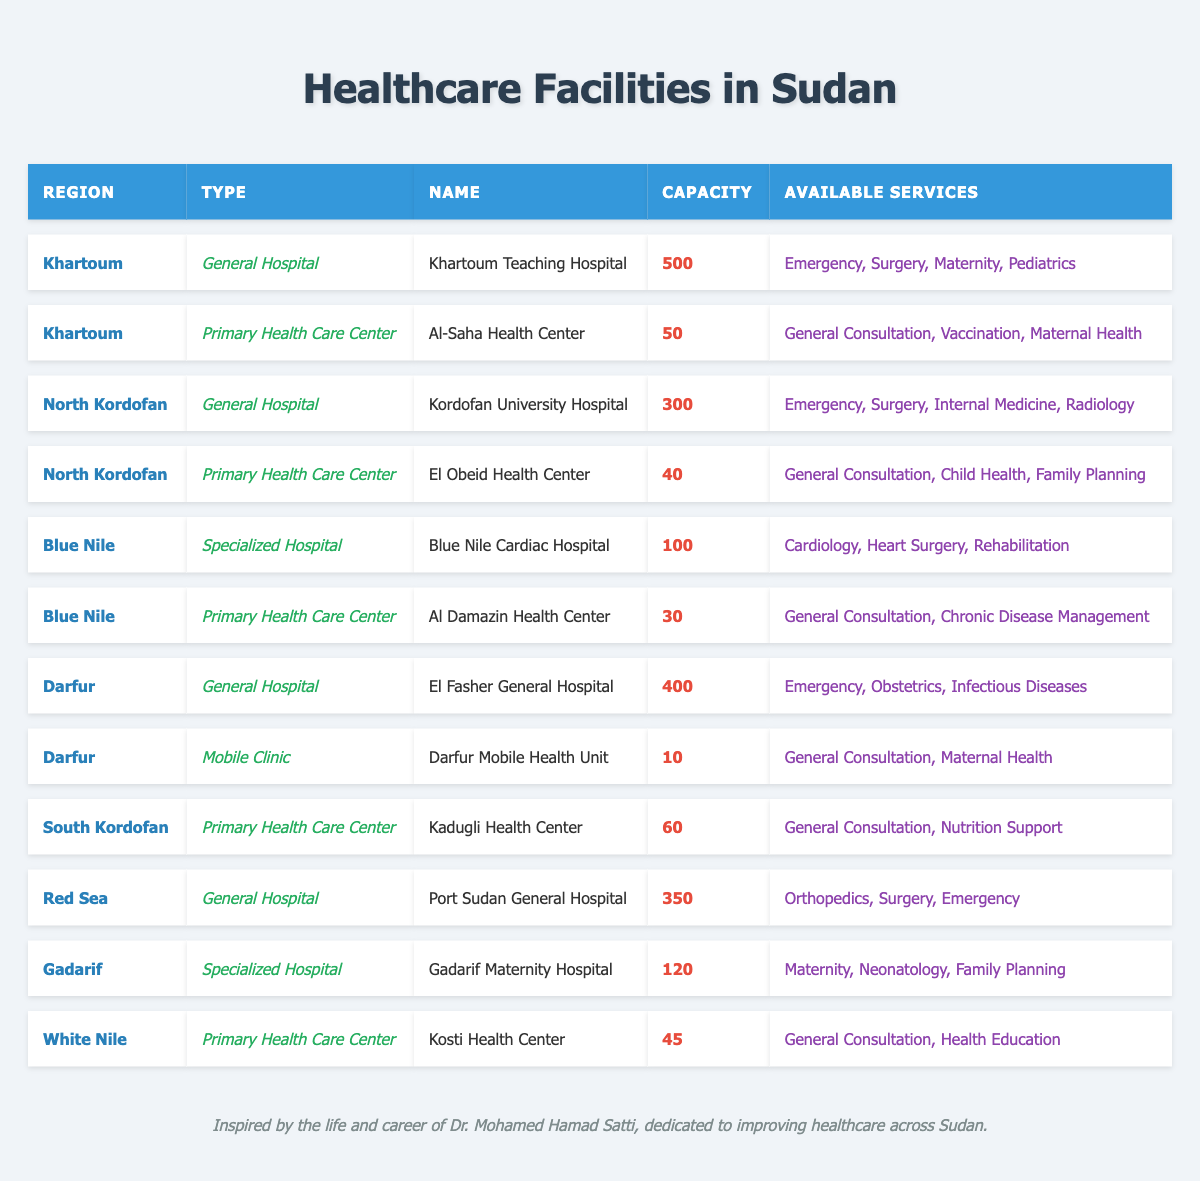What is the capacity of Khartoum Teaching Hospital? The table lists the capacity of Khartoum Teaching Hospital under the "Capacity" column, which shows it is 500.
Answer: 500 Which region has the highest capacity hospital? By comparing the capacities of all hospitals in the table, El Fasher General Hospital in the Darfur region has the highest capacity of 400.
Answer: Darfur How many primary health care centers are listed in the table? The table identifies three primary health care centers: Al-Saha Health Center, El Obeid Health Center, and Al Damazin Health Center, making a total of 6.
Answer: 6 What services are available at the Gadarif Maternity Hospital? The table specifies the available services for Gadarif Maternity Hospital, which are Maternity, Neonatology, and Family Planning.
Answer: Maternity, Neonatology, Family Planning Is there a mobile clinic in the Darfur region? The table shows the entry for Darfur that is a mobile clinic named Darfur Mobile Health Unit, confirming that there is one in that region.
Answer: Yes What is the total capacity of all the healthcare facilities listed in Blue Nile? In Blue Nile, the capacities of the facilities are 100 (Blue Nile Cardiac Hospital) + 30 (Al Damazin Health Center) = 130, which sums to 130.
Answer: 130 Which region has the least capacity for its primary health care center? Comparing the capacities of primary health care centers, Al Damazin Health Center in Blue Nile has the least capacity at 30.
Answer: Blue Nile Are there more general hospitals or primary health care centers in the table? The table shows 5 general hospitals and 6 primary health care centers. Since 6 is greater than 5, there are more primary health care centers.
Answer: Primary Health Care Centers What is the total capacity of healthcare facilities in the Red Sea region? The capacities of the healthcare facilities in the Red Sea are 350 (Port Sudan General Hospital). So, the total is just 350.
Answer: 350 How many services does the Kosti Health Center provide? The table lists Kosti Health Center under available services, which provides General Consultation and Health Education, totaling 2 services.
Answer: 2 